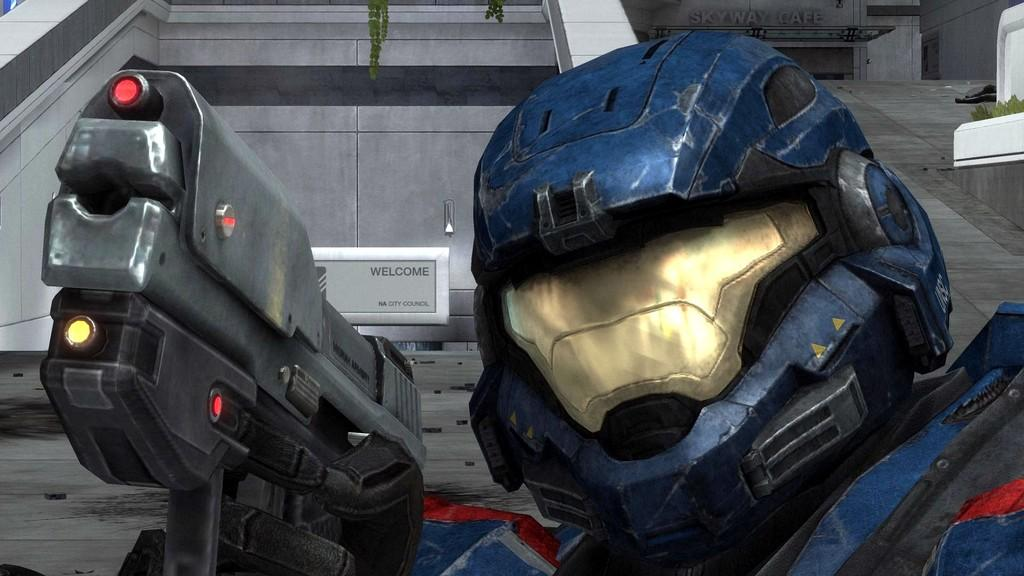What is the main subject in the image? There is a robot in the image. What is the robot holding? The robot is holding a weapon. What is visible behind the robot? There is a wall behind the robot. Where is the squirrel hiding in the image? There is no squirrel present in the image. What color is the sock that the robot is wearing in the image? The robot does not have any visible socks in the image. 